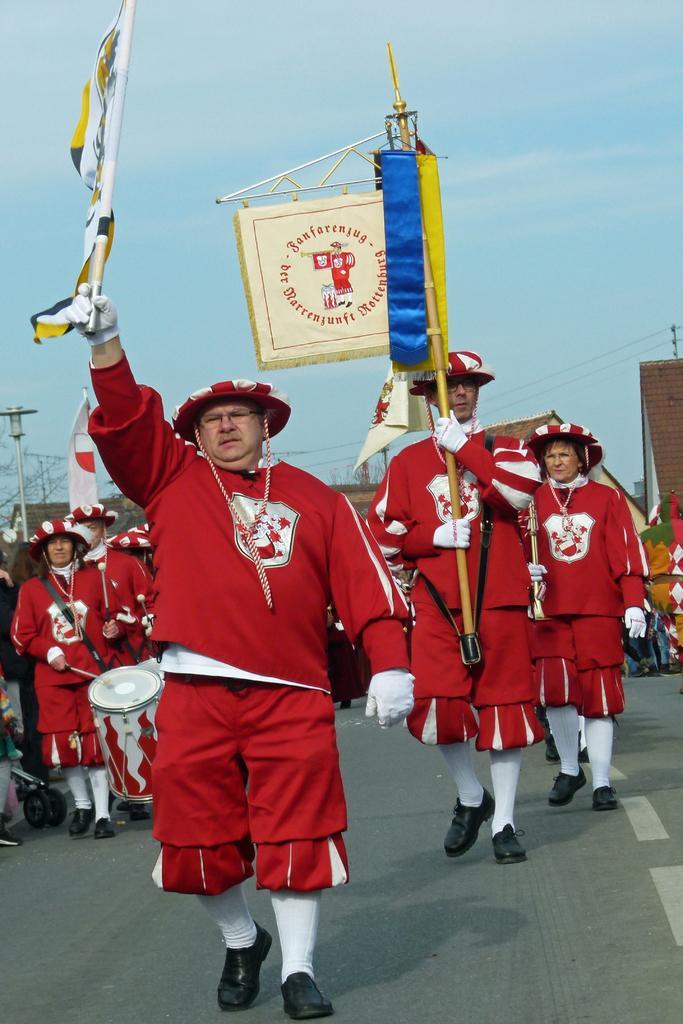Can you describe this image briefly? As we can see in the image there are group of people wearing red color dresses and in the background there are buildings. The man on the left side is playing drums. There is flag, banner and at the top there is sky. 